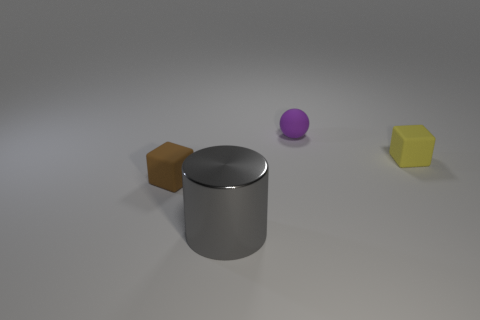Add 4 big purple rubber balls. How many objects exist? 8 Subtract all cylinders. How many objects are left? 3 Add 3 large gray cylinders. How many large gray cylinders are left? 4 Add 1 gray metallic cylinders. How many gray metallic cylinders exist? 2 Subtract 0 gray cubes. How many objects are left? 4 Subtract all matte blocks. Subtract all brown matte cubes. How many objects are left? 1 